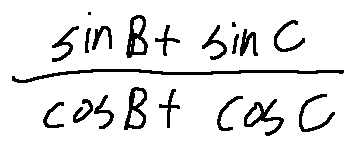Convert formula to latex. <formula><loc_0><loc_0><loc_500><loc_500>\frac { \sin B + \sin C } { \cos B + \cos C }</formula> 